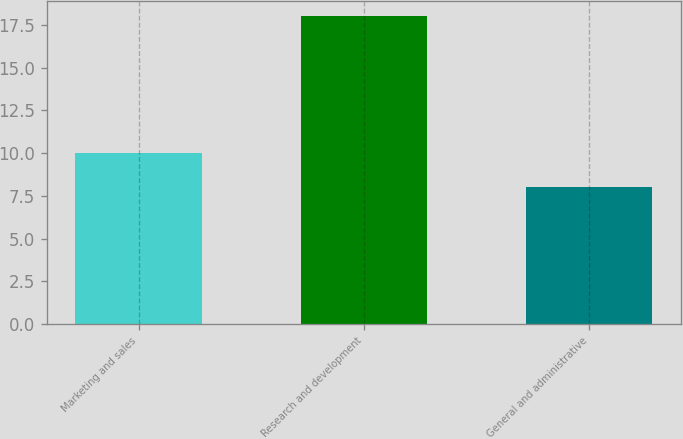Convert chart. <chart><loc_0><loc_0><loc_500><loc_500><bar_chart><fcel>Marketing and sales<fcel>Research and development<fcel>General and administrative<nl><fcel>10<fcel>18<fcel>8<nl></chart> 